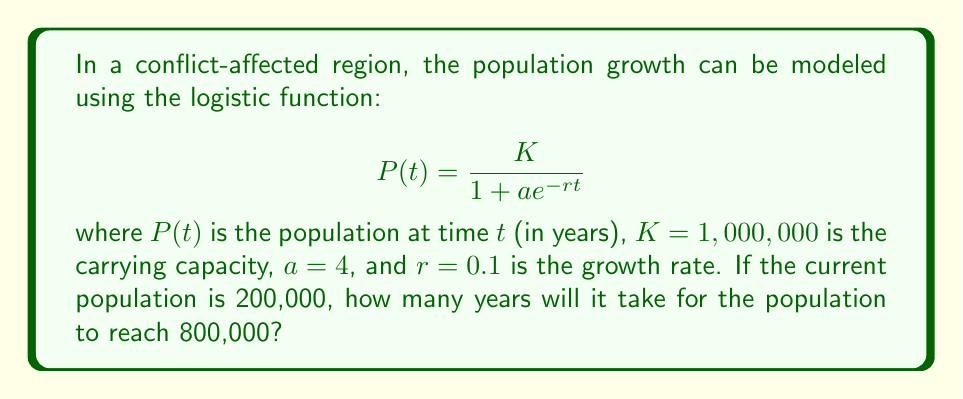Help me with this question. To solve this problem, we need to follow these steps:

1) We're given the logistic function: $$P(t) = \frac{K}{1 + ae^{-rt}}$$

2) We know that $K = 1,000,000$, $a = 4$, and $r = 0.1$. We need to find $t$ when $P(t) = 800,000$.

3) Let's substitute these values into the equation:

   $$800,000 = \frac{1,000,000}{1 + 4e^{-0.1t}}$$

4) Now, let's solve for $t$:

   $$\frac{800,000}{1,000,000} = \frac{1}{1 + 4e^{-0.1t}}$$

   $$0.8 = \frac{1}{1 + 4e^{-0.1t}}$$

5) Take the reciprocal of both sides:

   $$\frac{1}{0.8} = 1 + 4e^{-0.1t}$$

   $$1.25 = 1 + 4e^{-0.1t}$$

6) Subtract 1 from both sides:

   $$0.25 = 4e^{-0.1t}$$

7) Divide both sides by 4:

   $$0.0625 = e^{-0.1t}$$

8) Take the natural log of both sides:

   $$\ln(0.0625) = -0.1t$$

9) Solve for $t$:

   $$t = \frac{-\ln(0.0625)}{0.1} \approx 27.63$$

Therefore, it will take approximately 27.63 years for the population to reach 800,000.
Answer: 27.63 years 